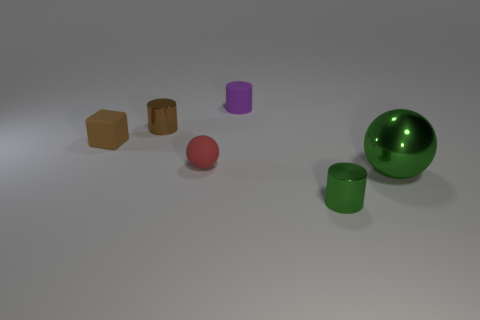Add 2 purple cylinders. How many objects exist? 8 Subtract all blocks. How many objects are left? 5 Add 4 green balls. How many green balls are left? 5 Add 5 yellow rubber cylinders. How many yellow rubber cylinders exist? 5 Subtract 1 green cylinders. How many objects are left? 5 Subtract all big green cylinders. Subtract all small green objects. How many objects are left? 5 